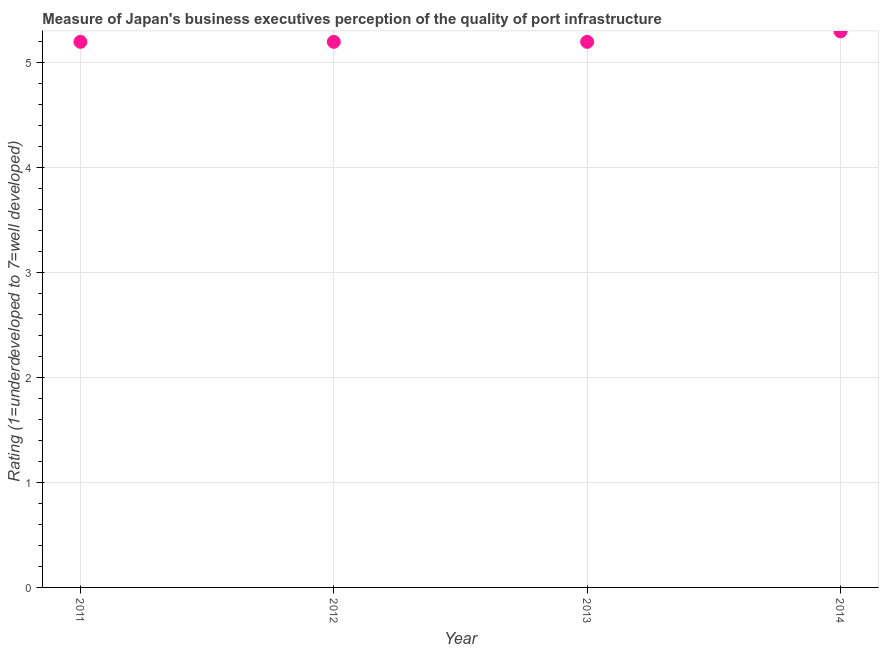What is the rating measuring quality of port infrastructure in 2012?
Offer a terse response. 5.2. Across all years, what is the minimum rating measuring quality of port infrastructure?
Make the answer very short. 5.2. In which year was the rating measuring quality of port infrastructure maximum?
Offer a terse response. 2014. In which year was the rating measuring quality of port infrastructure minimum?
Provide a short and direct response. 2011. What is the sum of the rating measuring quality of port infrastructure?
Provide a short and direct response. 20.9. What is the average rating measuring quality of port infrastructure per year?
Keep it short and to the point. 5.23. What is the median rating measuring quality of port infrastructure?
Your answer should be very brief. 5.2. In how many years, is the rating measuring quality of port infrastructure greater than 1.8 ?
Ensure brevity in your answer.  4. Do a majority of the years between 2011 and 2013 (inclusive) have rating measuring quality of port infrastructure greater than 2 ?
Ensure brevity in your answer.  Yes. What is the ratio of the rating measuring quality of port infrastructure in 2012 to that in 2014?
Offer a very short reply. 0.98. Is the difference between the rating measuring quality of port infrastructure in 2011 and 2014 greater than the difference between any two years?
Offer a very short reply. Yes. What is the difference between the highest and the second highest rating measuring quality of port infrastructure?
Make the answer very short. 0.1. Is the sum of the rating measuring quality of port infrastructure in 2011 and 2014 greater than the maximum rating measuring quality of port infrastructure across all years?
Ensure brevity in your answer.  Yes. What is the difference between the highest and the lowest rating measuring quality of port infrastructure?
Provide a succinct answer. 0.1. How many dotlines are there?
Give a very brief answer. 1. How many years are there in the graph?
Give a very brief answer. 4. What is the difference between two consecutive major ticks on the Y-axis?
Ensure brevity in your answer.  1. Are the values on the major ticks of Y-axis written in scientific E-notation?
Ensure brevity in your answer.  No. Does the graph contain grids?
Provide a short and direct response. Yes. What is the title of the graph?
Your answer should be compact. Measure of Japan's business executives perception of the quality of port infrastructure. What is the label or title of the Y-axis?
Provide a short and direct response. Rating (1=underdeveloped to 7=well developed) . What is the Rating (1=underdeveloped to 7=well developed)  in 2012?
Make the answer very short. 5.2. What is the Rating (1=underdeveloped to 7=well developed)  in 2014?
Offer a very short reply. 5.3. What is the difference between the Rating (1=underdeveloped to 7=well developed)  in 2011 and 2012?
Offer a very short reply. 0. What is the difference between the Rating (1=underdeveloped to 7=well developed)  in 2011 and 2014?
Your answer should be very brief. -0.1. What is the difference between the Rating (1=underdeveloped to 7=well developed)  in 2012 and 2013?
Keep it short and to the point. 0. What is the difference between the Rating (1=underdeveloped to 7=well developed)  in 2012 and 2014?
Offer a terse response. -0.1. What is the ratio of the Rating (1=underdeveloped to 7=well developed)  in 2011 to that in 2012?
Your response must be concise. 1. What is the ratio of the Rating (1=underdeveloped to 7=well developed)  in 2013 to that in 2014?
Offer a very short reply. 0.98. 